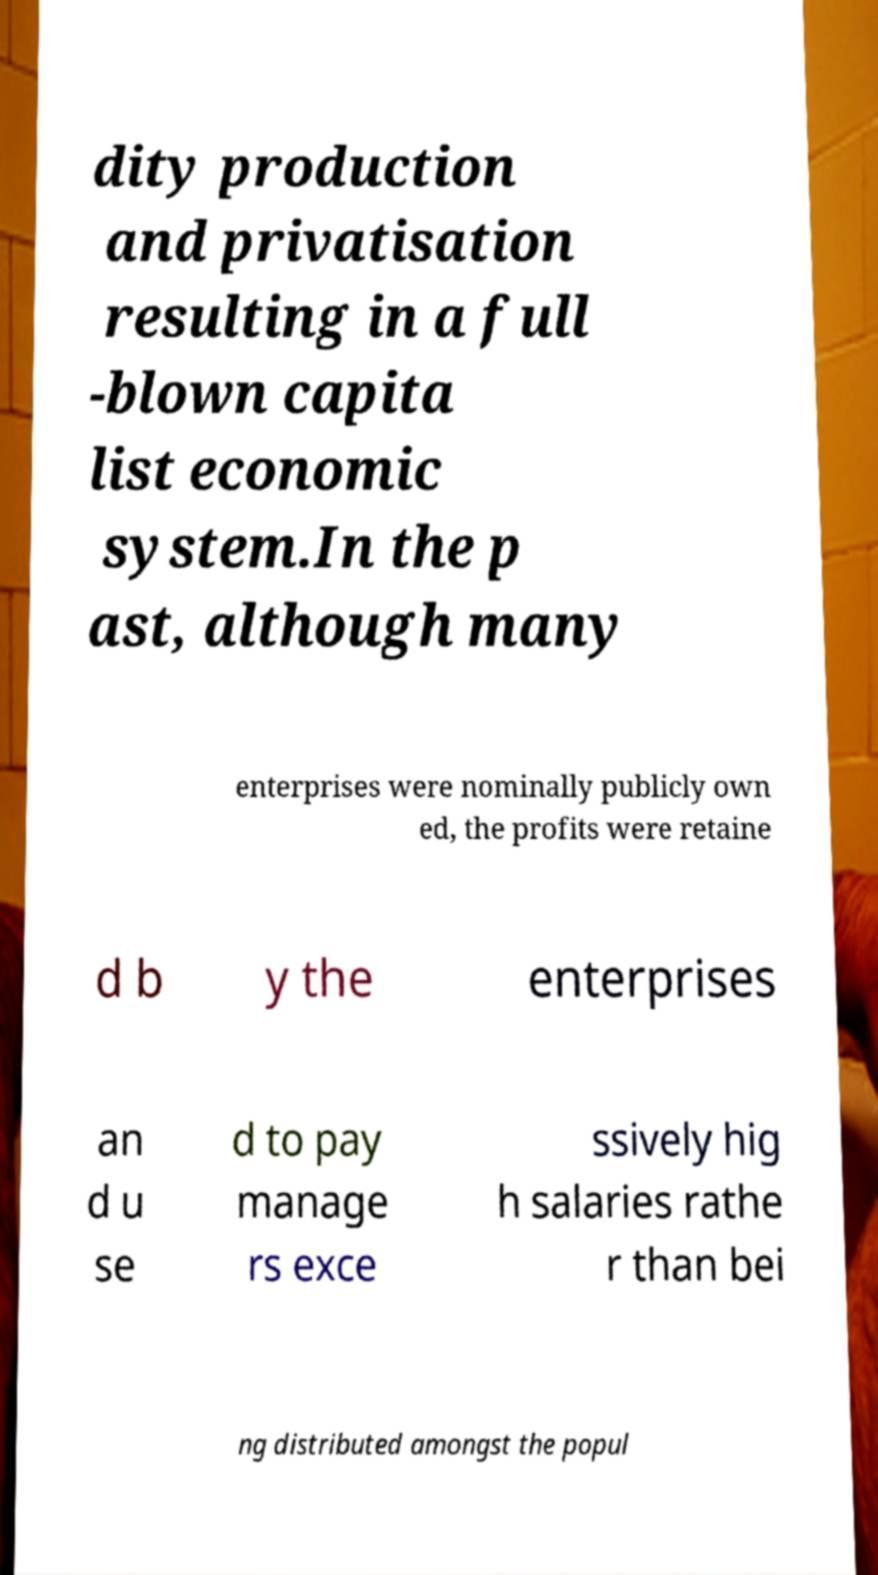Could you extract and type out the text from this image? dity production and privatisation resulting in a full -blown capita list economic system.In the p ast, although many enterprises were nominally publicly own ed, the profits were retaine d b y the enterprises an d u se d to pay manage rs exce ssively hig h salaries rathe r than bei ng distributed amongst the popul 